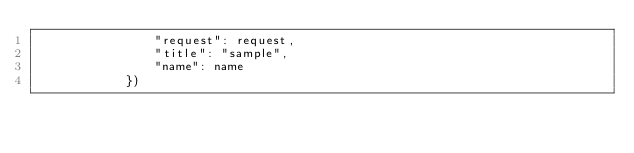Convert code to text. <code><loc_0><loc_0><loc_500><loc_500><_Python_>                "request": request,
                "title": "sample",
                "name": name
            })
</code> 